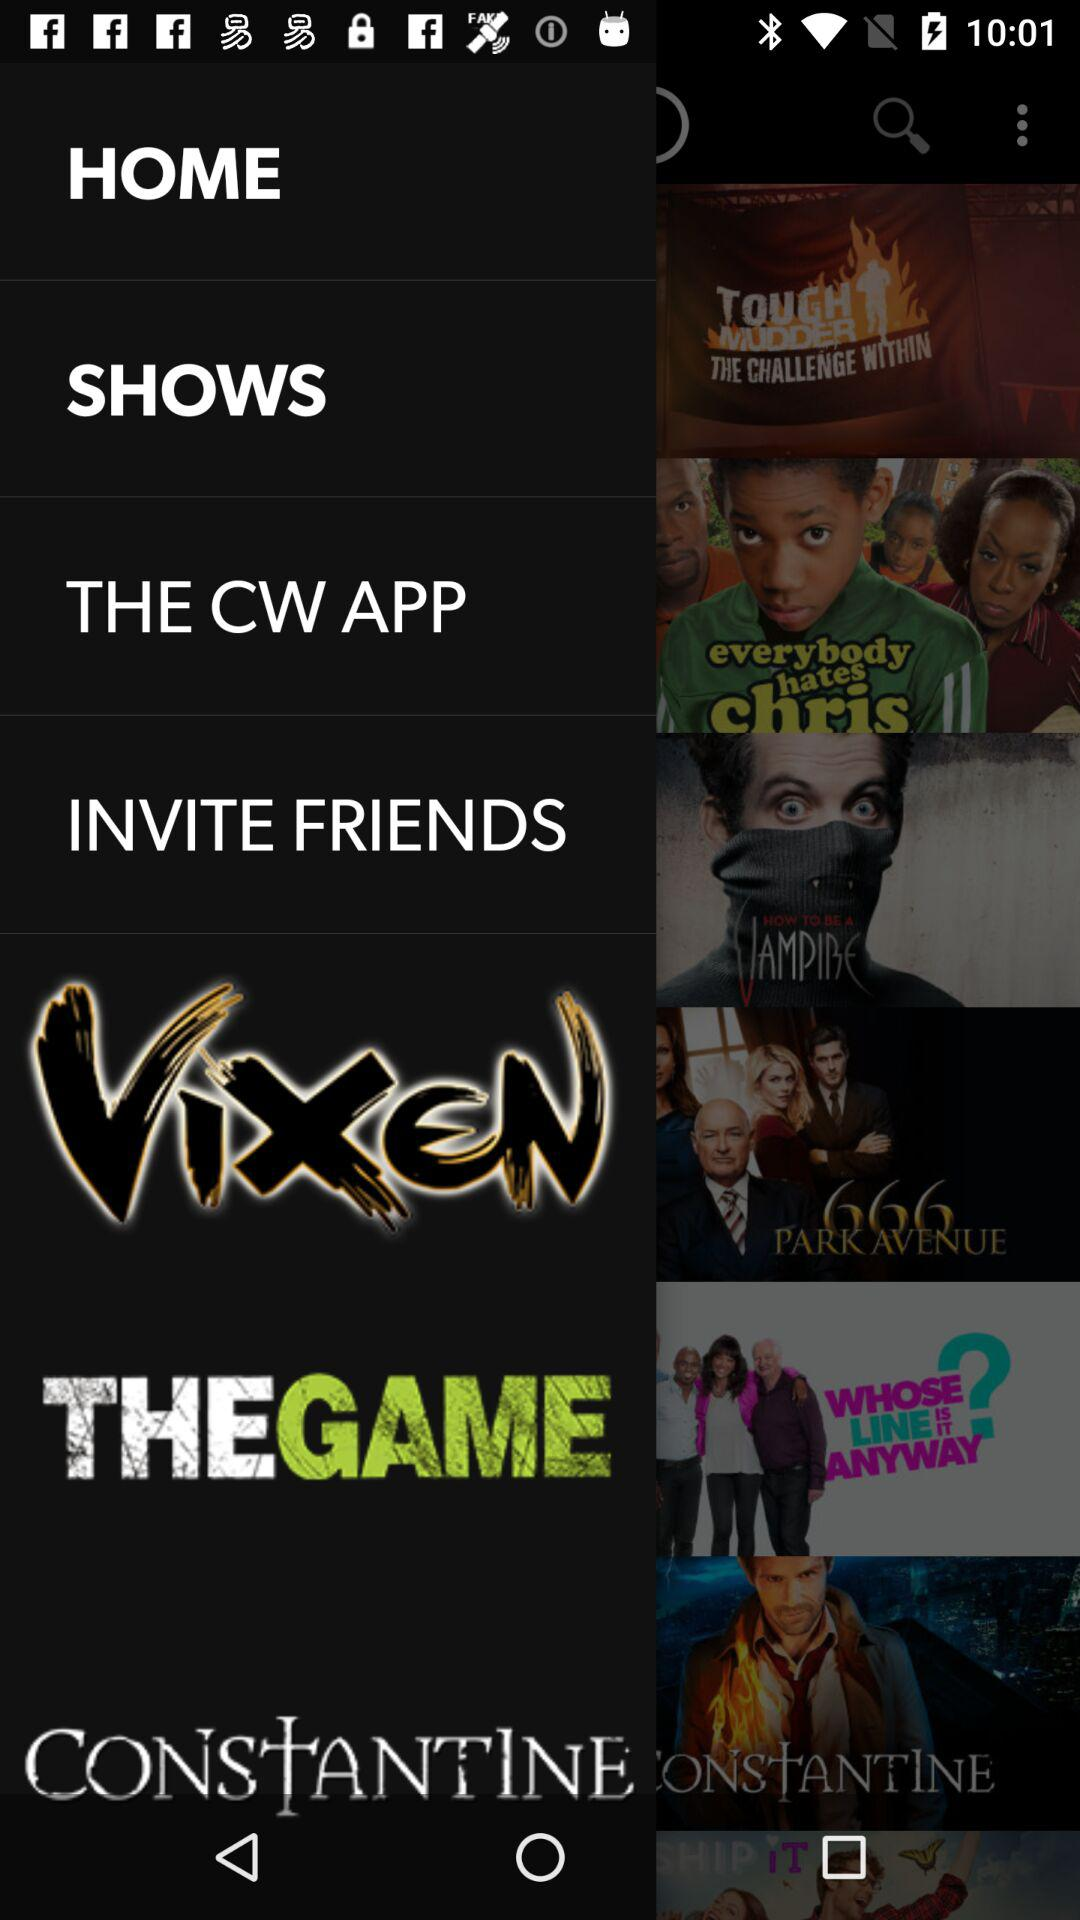How many items have a text label?
Answer the question using a single word or phrase. 6 